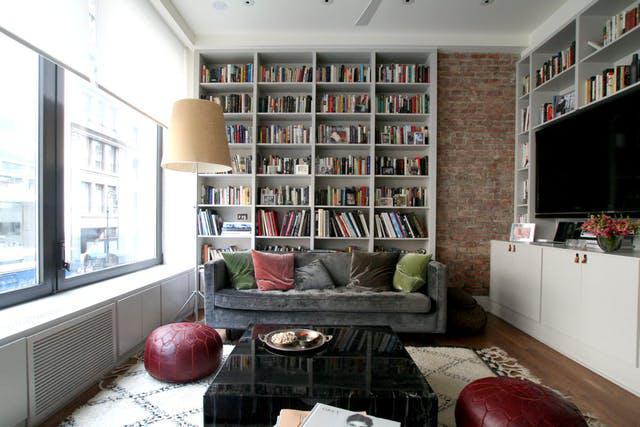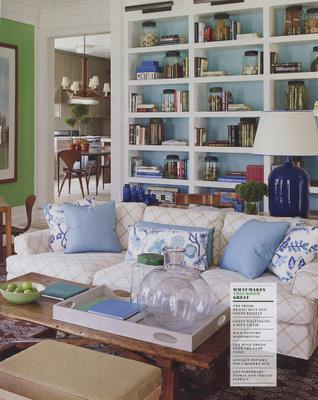The first image is the image on the left, the second image is the image on the right. For the images shown, is this caption "An image features a round white table in front of a horizontal couch with assorted pillows, which is in front of a white bookcase." true? Answer yes or no. No. The first image is the image on the left, the second image is the image on the right. Evaluate the accuracy of this statement regarding the images: "One of the tables is small, white, and round.". Is it true? Answer yes or no. No. 